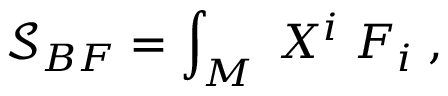Convert formula to latex. <formula><loc_0><loc_0><loc_500><loc_500>\mathcal { S } _ { B F } = \int _ { M } \, X ^ { i } \, F _ { i } \, ,</formula> 